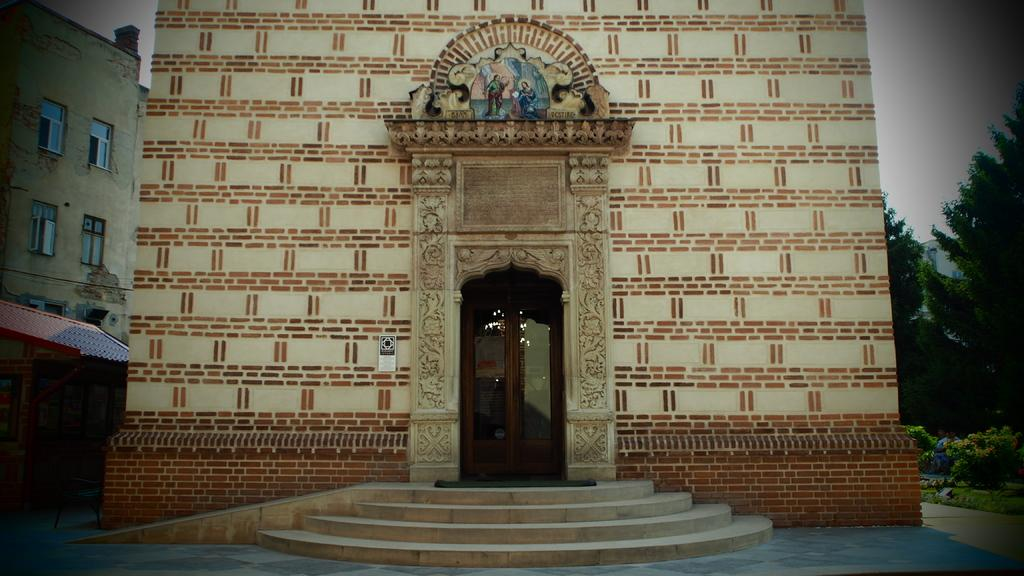What type of structures are visible in the image? There are buildings with windows in the image. What architectural feature can be seen in the image? There are steps in the image. What type of object is present to provide shade? There are sun shades in the image. What can be used to enter or exit the buildings? There are doors in the image. What artistic element is present in the image? There is a statue in the image. What type of vegetation is present in the image? There are trees and plants in the image. What is visible in the background of the image? The sky is visible in the background of the image. What type of card is being used to play a game in the image? There is no card or game present in the image. What type of shirt is the person wearing in the image? There is no person or shirt present in the image. 